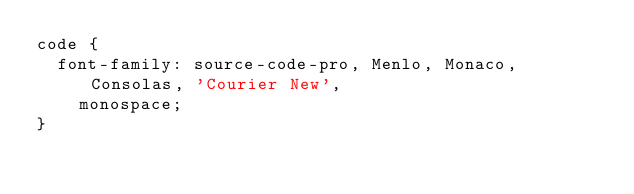Convert code to text. <code><loc_0><loc_0><loc_500><loc_500><_CSS_>code {
  font-family: source-code-pro, Menlo, Monaco, Consolas, 'Courier New',
    monospace;
}
</code> 